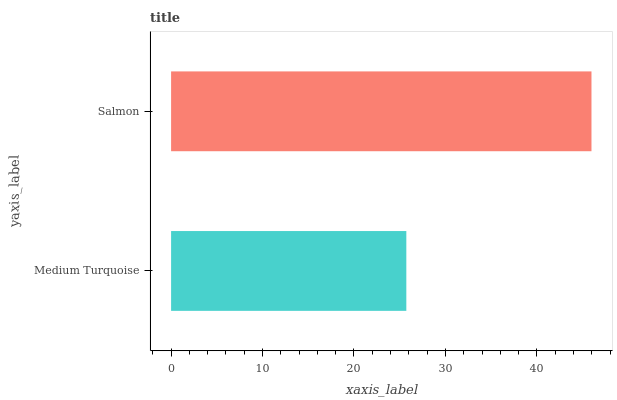Is Medium Turquoise the minimum?
Answer yes or no. Yes. Is Salmon the maximum?
Answer yes or no. Yes. Is Salmon the minimum?
Answer yes or no. No. Is Salmon greater than Medium Turquoise?
Answer yes or no. Yes. Is Medium Turquoise less than Salmon?
Answer yes or no. Yes. Is Medium Turquoise greater than Salmon?
Answer yes or no. No. Is Salmon less than Medium Turquoise?
Answer yes or no. No. Is Salmon the high median?
Answer yes or no. Yes. Is Medium Turquoise the low median?
Answer yes or no. Yes. Is Medium Turquoise the high median?
Answer yes or no. No. Is Salmon the low median?
Answer yes or no. No. 